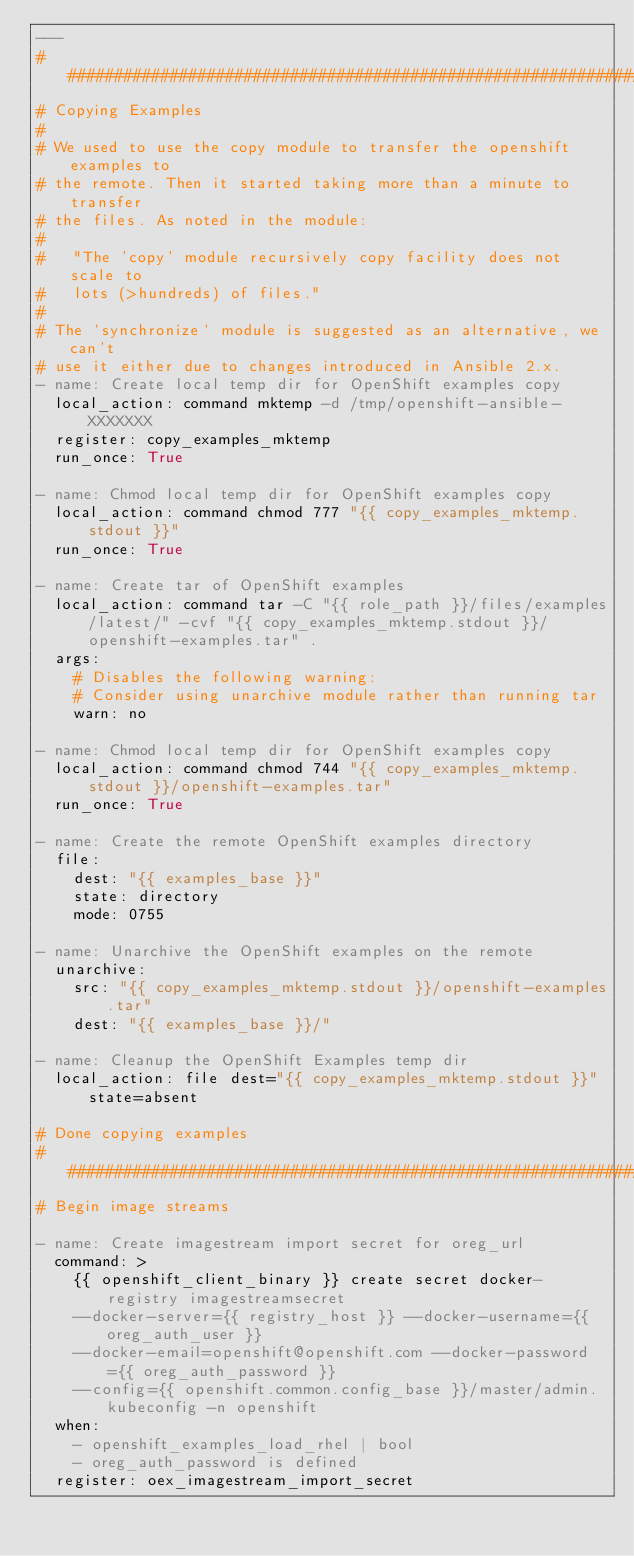<code> <loc_0><loc_0><loc_500><loc_500><_YAML_>---
######################################################################
# Copying Examples
#
# We used to use the copy module to transfer the openshift examples to
# the remote. Then it started taking more than a minute to transfer
# the files. As noted in the module:
#
#   "The 'copy' module recursively copy facility does not scale to
#   lots (>hundreds) of files."
#
# The `synchronize` module is suggested as an alternative, we can't
# use it either due to changes introduced in Ansible 2.x.
- name: Create local temp dir for OpenShift examples copy
  local_action: command mktemp -d /tmp/openshift-ansible-XXXXXXX
  register: copy_examples_mktemp
  run_once: True

- name: Chmod local temp dir for OpenShift examples copy
  local_action: command chmod 777 "{{ copy_examples_mktemp.stdout }}"
  run_once: True

- name: Create tar of OpenShift examples
  local_action: command tar -C "{{ role_path }}/files/examples/latest/" -cvf "{{ copy_examples_mktemp.stdout }}/openshift-examples.tar" .
  args:
    # Disables the following warning:
    # Consider using unarchive module rather than running tar
    warn: no

- name: Chmod local temp dir for OpenShift examples copy
  local_action: command chmod 744 "{{ copy_examples_mktemp.stdout }}/openshift-examples.tar"
  run_once: True

- name: Create the remote OpenShift examples directory
  file:
    dest: "{{ examples_base }}"
    state: directory
    mode: 0755

- name: Unarchive the OpenShift examples on the remote
  unarchive:
    src: "{{ copy_examples_mktemp.stdout }}/openshift-examples.tar"
    dest: "{{ examples_base }}/"

- name: Cleanup the OpenShift Examples temp dir
  local_action: file dest="{{ copy_examples_mktemp.stdout }}" state=absent

# Done copying examples
######################################################################
# Begin image streams

- name: Create imagestream import secret for oreg_url
  command: >
    {{ openshift_client_binary }} create secret docker-registry imagestreamsecret
    --docker-server={{ registry_host }} --docker-username={{ oreg_auth_user }}
    --docker-email=openshift@openshift.com --docker-password={{ oreg_auth_password }}
    --config={{ openshift.common.config_base }}/master/admin.kubeconfig -n openshift
  when:
    - openshift_examples_load_rhel | bool
    - oreg_auth_password is defined
  register: oex_imagestream_import_secret</code> 